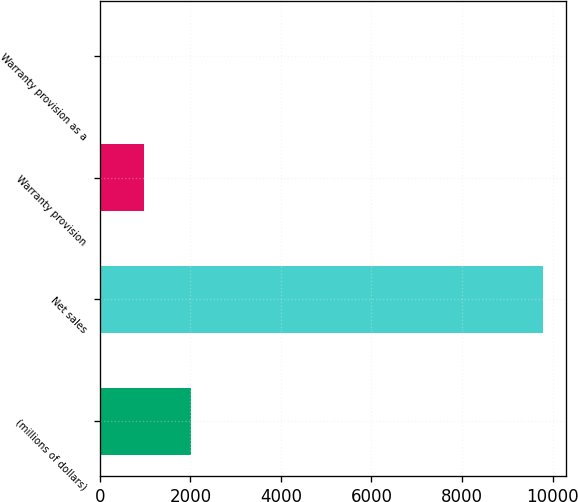<chart> <loc_0><loc_0><loc_500><loc_500><bar_chart><fcel>(millions of dollars)<fcel>Net sales<fcel>Warranty provision<fcel>Warranty provision as a<nl><fcel>2017<fcel>9799.3<fcel>980.56<fcel>0.7<nl></chart> 